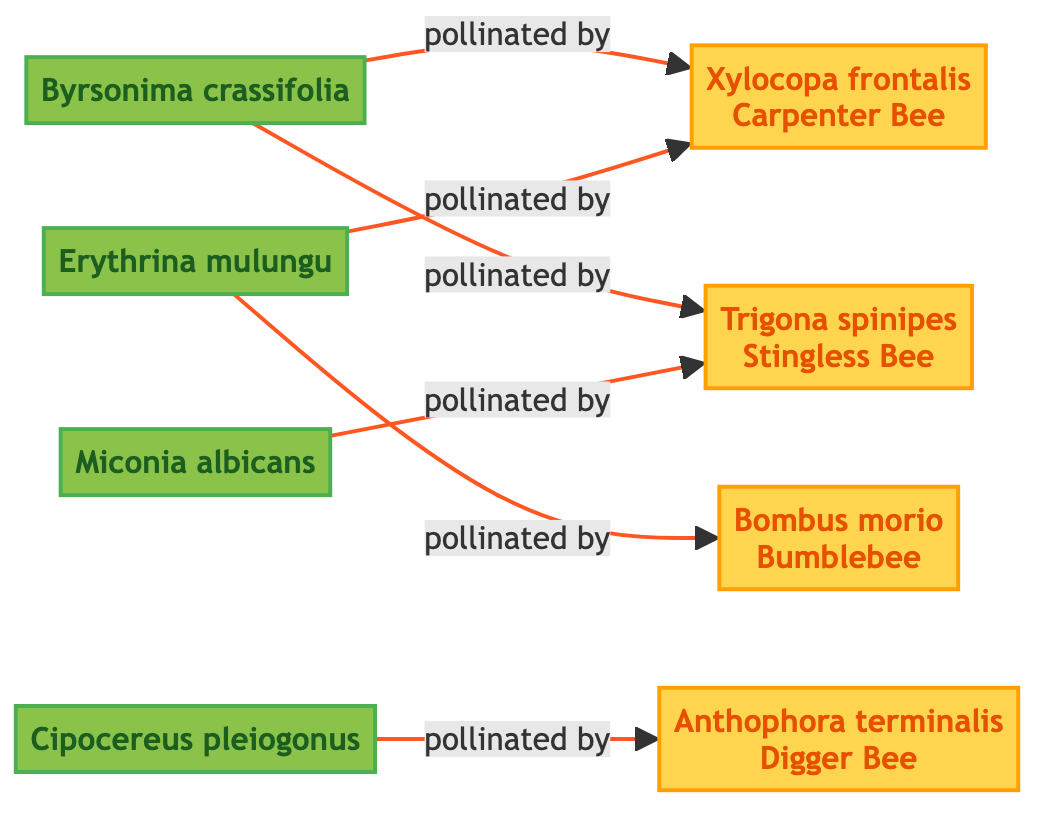What are the plant species in the diagram? The diagram shows four plant species: Byrsonima crassifolia, Erythrina mulungu, Miconia albicans, and Cipocereus pleiogonus. Each is represented by a node labeled with their names.
Answer: Byrsonima crassifolia, Erythrina mulungu, Miconia albicans, Cipocereus pleiogonus Which pollinator is linked to Byrsonima crassifolia? The connections from the node representing Byrsonima crassifolia show that it is pollinated by Xylocopa frontalis and Trigona spinipes. We can identify these relationships directly from the arrows in the diagram.
Answer: Xylocopa frontalis, Trigona spinipes How many pollinator species are included in the diagram? The diagram displays four unique pollinator species: Xylocopa frontalis, Bombus morio, Trigona spinipes, and Anthophora terminalis. Counting these throughout the diagram leads to the answer.
Answer: 4 Which plant species is pollinated by Anthophora terminalis? Looking at the connections, the node representing Cipocereus pleiogonus has a directed link indicating it is pollinated by Anthophora terminalis. The arrows denote the direction of the relationship.
Answer: Cipocereus pleiogonus What common pollinator is shared between Erythrina mulungu and Byrsonima crassifolia? Both Erythrina mulungu and Byrsonima crassifolia are shown to be pollinated by Xylocopa frontalis, which can be seen as both plants have arrows connecting them to this specific pollinator.
Answer: Xylocopa frontalis How many total connections (pollination links) are there in the diagram? By counting each directed link in the diagram: Byrsonima crassifolia has 2 links, Erythrina mulungu has 2 links, Miconia albicans has 1 link, and Cipocereus pleiogonus has 1 link, totaling 6.
Answer: 6 Which pollinator has the most connections in the diagram? Upon examining the pollinators, Xylocopa frontalis is linked to 2 plant species, while other pollinators are linked to either 1 or 2, making Xylocopa frontalis the most connected.
Answer: Xylocopa frontalis Which plant is only pollinated by one specific pollinator? Cipocereus pleiogonus is the only plant in the diagram that has a single pollination link to Anthophora terminalis. This can be directly observed from its connection within the diagram.
Answer: Cipocereus pleiogonus 